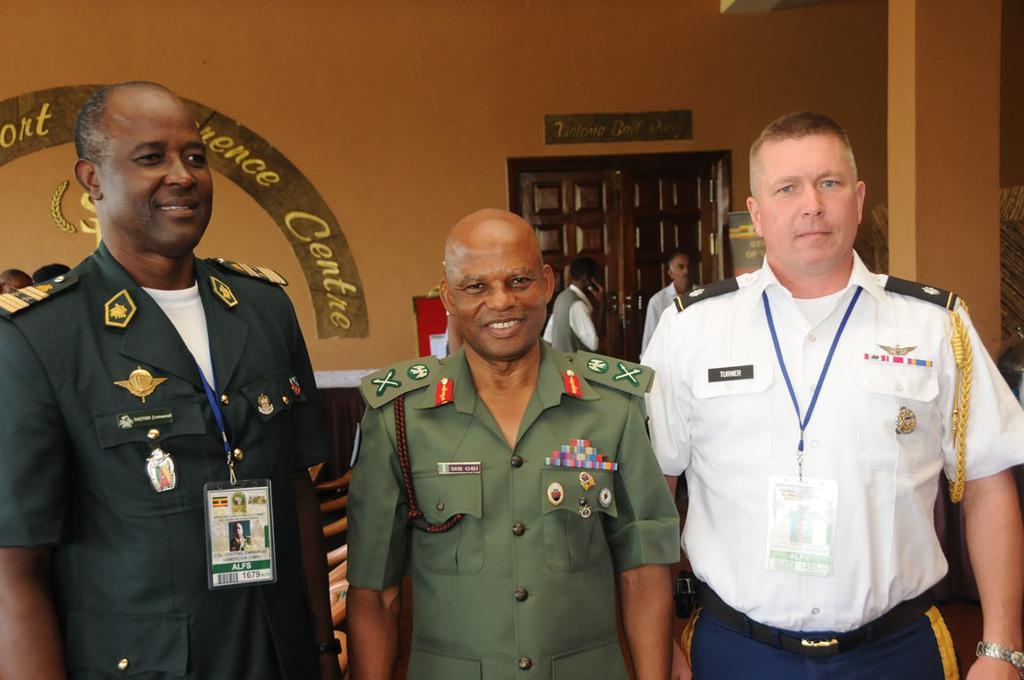Describe this image in one or two sentences. In this image in the front of there are persons standing and smiling. In the background on the wall there is some text written on it and there is a door and there are persons. 